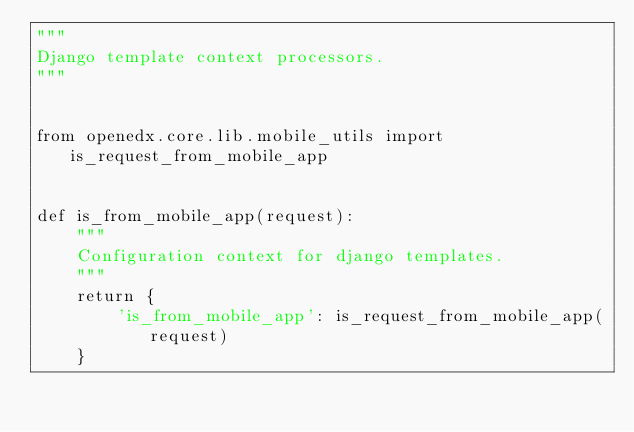<code> <loc_0><loc_0><loc_500><loc_500><_Python_>"""
Django template context processors.
"""


from openedx.core.lib.mobile_utils import is_request_from_mobile_app


def is_from_mobile_app(request):
    """
    Configuration context for django templates.
    """
    return {
        'is_from_mobile_app': is_request_from_mobile_app(request)
    }
</code> 